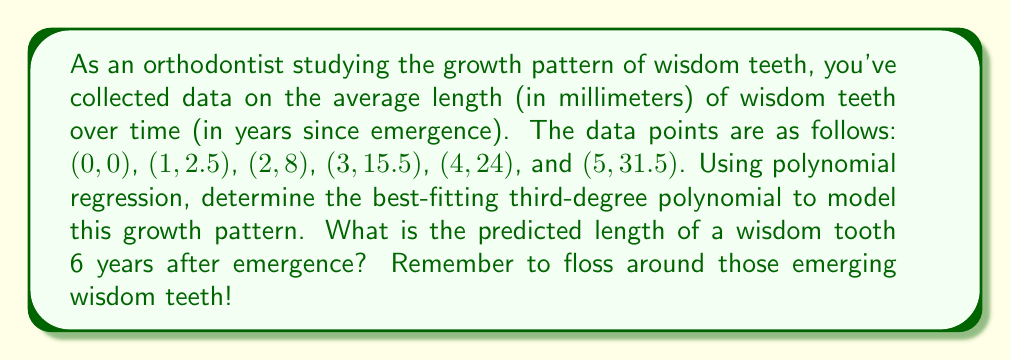Show me your answer to this math problem. To solve this problem, we'll use polynomial regression to find the best-fitting third-degree polynomial. Let's follow these steps:

1) The general form of a third-degree polynomial is:
   $$f(x) = ax^3 + bx^2 + cx + d$$

2) We need to solve the following system of equations:
   $$\sum y = an\sum x^3 + b\sum x^2 + c\sum x + nd$$
   $$\sum xy = a\sum x^4 + b\sum x^3 + c\sum x^2 + d\sum x$$
   $$\sum x^2y = a\sum x^5 + b\sum x^4 + c\sum x^3 + d\sum x^2$$
   $$\sum x^3y = a\sum x^6 + b\sum x^5 + c\sum x^4 + d\sum x^3$$

3) Calculate the necessary sums:
   $\sum x = 15$, $\sum x^2 = 55$, $\sum x^3 = 225$, $\sum x^4 = 979$, $\sum x^5 = 4425$, $\sum x^6 = 20615$
   $\sum y = 81.5$, $\sum xy = 309.5$, $\sum x^2y = 1268.5$, $\sum x^3y = 5400.5$

4) Substitute these values into the system of equations:
   $$81.5 = 225a + 55b + 15c + 6d$$
   $$309.5 = 979a + 225b + 55c + 15d$$
   $$1268.5 = 4425a + 979b + 225c + 55d$$
   $$5400.5 = 20615a + 4425b + 979c + 225d$$

5) Solve this system of equations using a matrix method or elimination. The solution is:
   $$a = -0.125, b = 1.875, c = 0.75, d = 0$$

6) Therefore, the best-fitting third-degree polynomial is:
   $$f(x) = -0.125x^3 + 1.875x^2 + 0.75x$$

7) To predict the length of a wisdom tooth 6 years after emergence, substitute x = 6 into this equation:
   $$f(6) = -0.125(6^3) + 1.875(6^2) + 0.75(6) = -27 + 67.5 + 4.5 = 45$$

Thus, the predicted length of a wisdom tooth 6 years after emergence is 45 mm.
Answer: 45 mm 